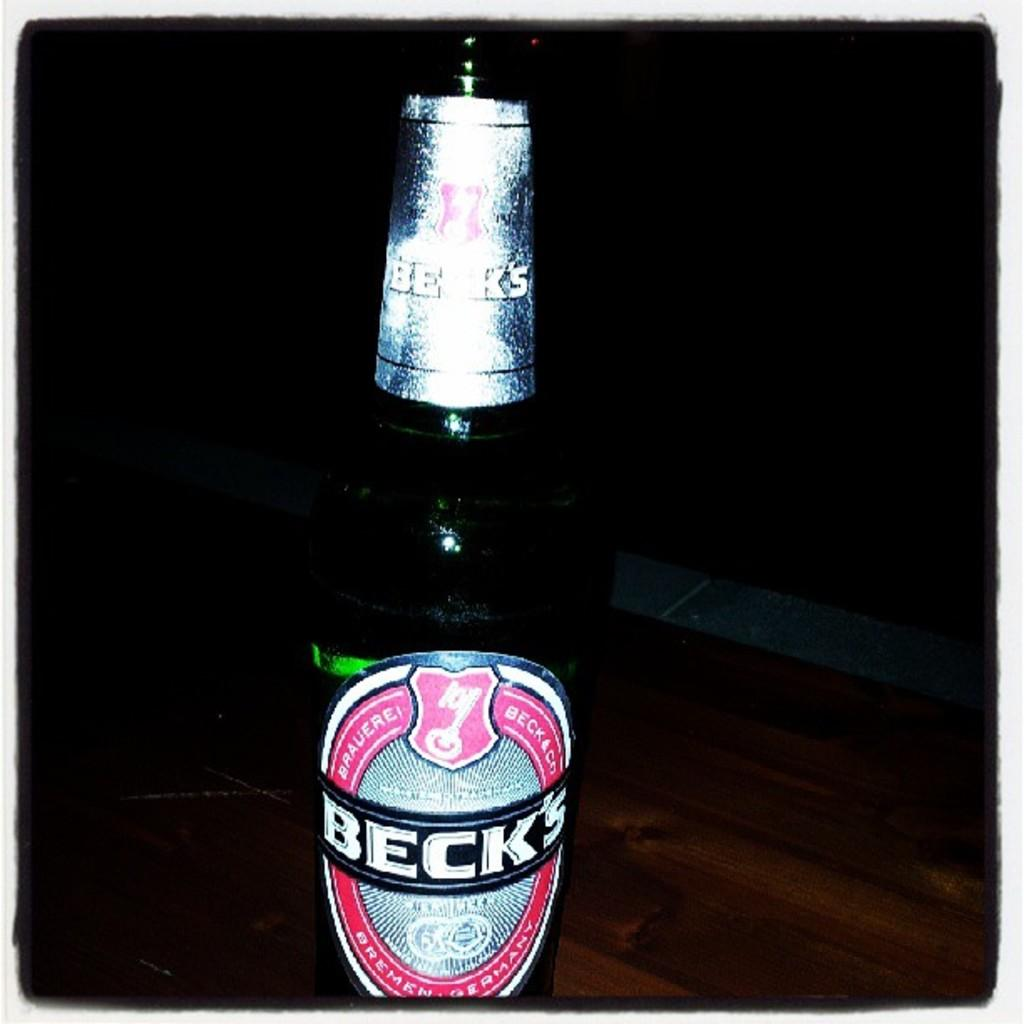Provide a one-sentence caption for the provided image. A bottle of Beck's sits on a table in the dark. 